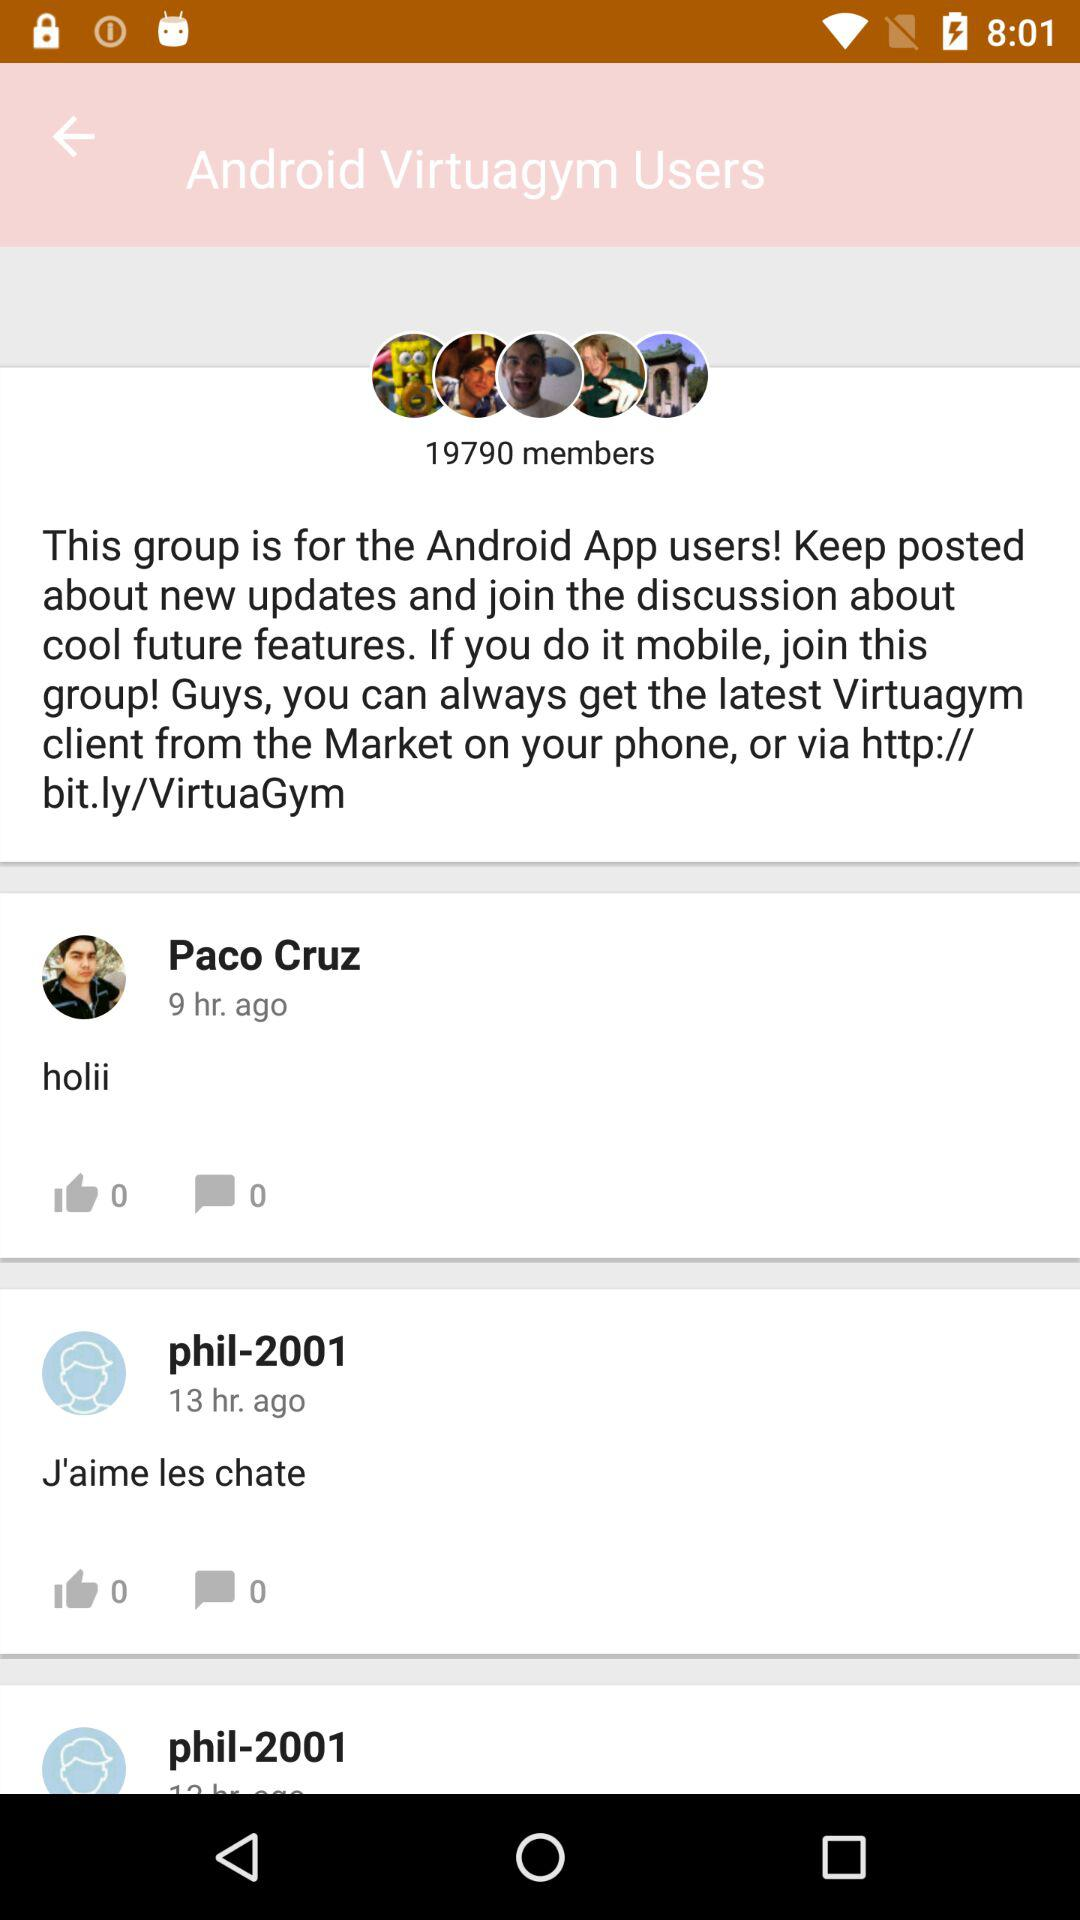How many members are there in the group?
Answer the question using a single word or phrase. 19790 